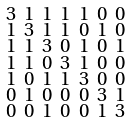<formula> <loc_0><loc_0><loc_500><loc_500>\begin{smallmatrix} 3 & 1 & 1 & 1 & 1 & 0 & 0 \\ 1 & 3 & 1 & 1 & 0 & 1 & 0 \\ 1 & 1 & 3 & 0 & 1 & 0 & 1 \\ 1 & 1 & 0 & 3 & 1 & 0 & 0 \\ 1 & 0 & 1 & 1 & 3 & 0 & 0 \\ 0 & 1 & 0 & 0 & 0 & 3 & 1 \\ 0 & 0 & 1 & 0 & 0 & 1 & 3 \end{smallmatrix}</formula> 